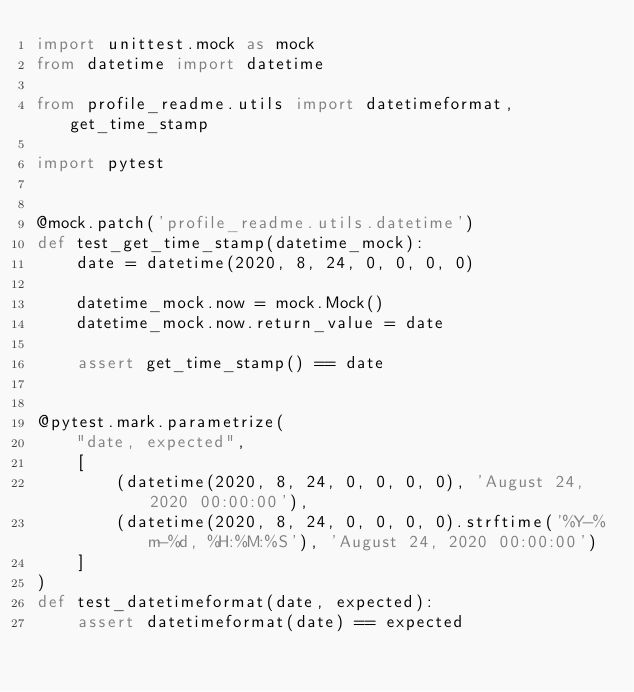<code> <loc_0><loc_0><loc_500><loc_500><_Python_>import unittest.mock as mock
from datetime import datetime

from profile_readme.utils import datetimeformat, get_time_stamp

import pytest


@mock.patch('profile_readme.utils.datetime')
def test_get_time_stamp(datetime_mock):
    date = datetime(2020, 8, 24, 0, 0, 0, 0)

    datetime_mock.now = mock.Mock()
    datetime_mock.now.return_value = date

    assert get_time_stamp() == date


@pytest.mark.parametrize(
    "date, expected",
    [
        (datetime(2020, 8, 24, 0, 0, 0, 0), 'August 24, 2020 00:00:00'),
        (datetime(2020, 8, 24, 0, 0, 0, 0).strftime('%Y-%m-%d, %H:%M:%S'), 'August 24, 2020 00:00:00')
    ]
)
def test_datetimeformat(date, expected):
    assert datetimeformat(date) == expected
</code> 